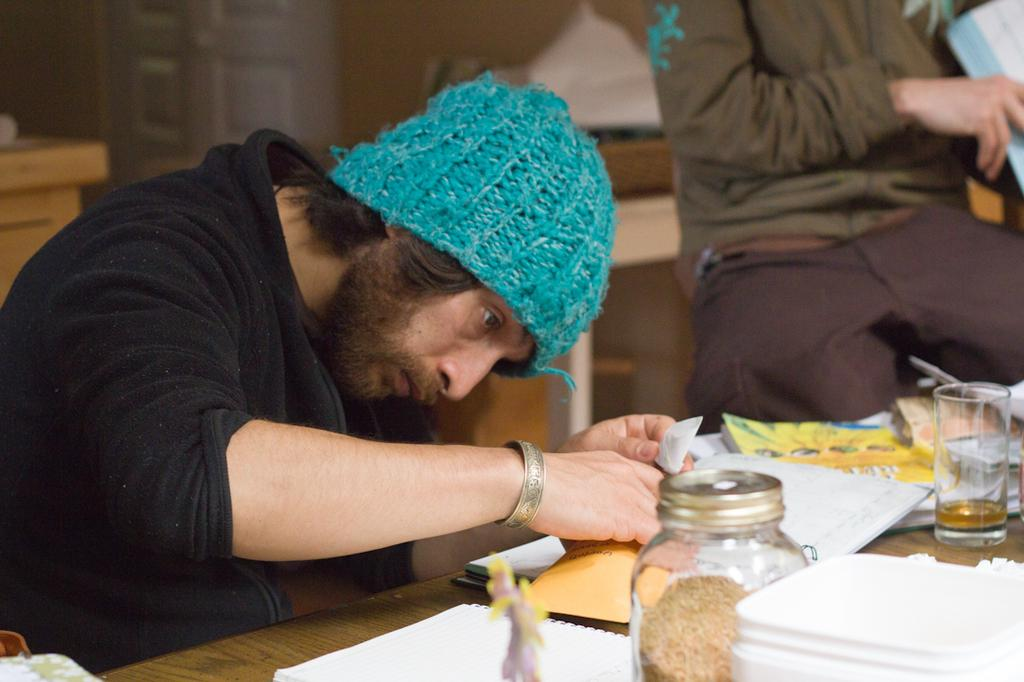Who is present in the image? There is a man in the image. What is the man doing in the image? The man is looking at papers. What objects can be seen on the table in the image? There is a glass jar and a glass on the table. Can you describe the person in the top right hand side of the image? There is a person in the top right hand side of the image, but no specific details are provided about them. How many chairs are visible in the image? There is no mention of chairs in the provided facts, so we cannot determine the number of chairs in the image. 